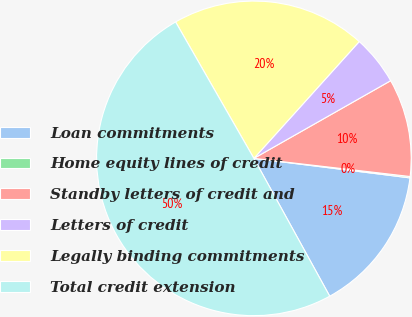Convert chart. <chart><loc_0><loc_0><loc_500><loc_500><pie_chart><fcel>Loan commitments<fcel>Home equity lines of credit<fcel>Standby letters of credit and<fcel>Letters of credit<fcel>Legally binding commitments<fcel>Total credit extension<nl><fcel>15.01%<fcel>0.14%<fcel>10.06%<fcel>5.1%<fcel>19.97%<fcel>49.71%<nl></chart> 